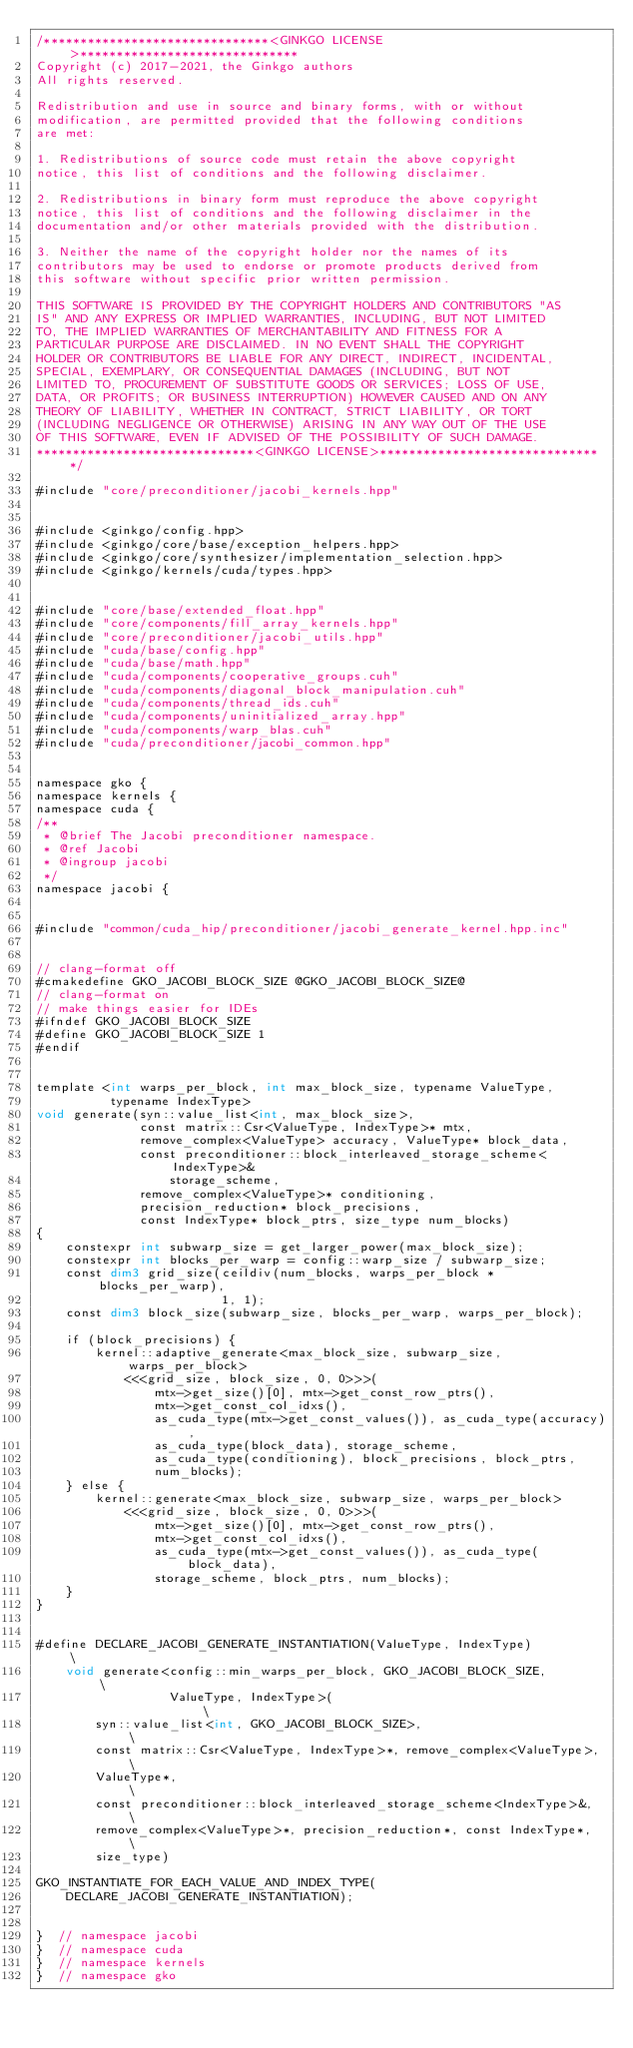<code> <loc_0><loc_0><loc_500><loc_500><_Cuda_>/*******************************<GINKGO LICENSE>******************************
Copyright (c) 2017-2021, the Ginkgo authors
All rights reserved.

Redistribution and use in source and binary forms, with or without
modification, are permitted provided that the following conditions
are met:

1. Redistributions of source code must retain the above copyright
notice, this list of conditions and the following disclaimer.

2. Redistributions in binary form must reproduce the above copyright
notice, this list of conditions and the following disclaimer in the
documentation and/or other materials provided with the distribution.

3. Neither the name of the copyright holder nor the names of its
contributors may be used to endorse or promote products derived from
this software without specific prior written permission.

THIS SOFTWARE IS PROVIDED BY THE COPYRIGHT HOLDERS AND CONTRIBUTORS "AS
IS" AND ANY EXPRESS OR IMPLIED WARRANTIES, INCLUDING, BUT NOT LIMITED
TO, THE IMPLIED WARRANTIES OF MERCHANTABILITY AND FITNESS FOR A
PARTICULAR PURPOSE ARE DISCLAIMED. IN NO EVENT SHALL THE COPYRIGHT
HOLDER OR CONTRIBUTORS BE LIABLE FOR ANY DIRECT, INDIRECT, INCIDENTAL,
SPECIAL, EXEMPLARY, OR CONSEQUENTIAL DAMAGES (INCLUDING, BUT NOT
LIMITED TO, PROCUREMENT OF SUBSTITUTE GOODS OR SERVICES; LOSS OF USE,
DATA, OR PROFITS; OR BUSINESS INTERRUPTION) HOWEVER CAUSED AND ON ANY
THEORY OF LIABILITY, WHETHER IN CONTRACT, STRICT LIABILITY, OR TORT
(INCLUDING NEGLIGENCE OR OTHERWISE) ARISING IN ANY WAY OUT OF THE USE
OF THIS SOFTWARE, EVEN IF ADVISED OF THE POSSIBILITY OF SUCH DAMAGE.
******************************<GINKGO LICENSE>*******************************/

#include "core/preconditioner/jacobi_kernels.hpp"


#include <ginkgo/config.hpp>
#include <ginkgo/core/base/exception_helpers.hpp>
#include <ginkgo/core/synthesizer/implementation_selection.hpp>
#include <ginkgo/kernels/cuda/types.hpp>


#include "core/base/extended_float.hpp"
#include "core/components/fill_array_kernels.hpp"
#include "core/preconditioner/jacobi_utils.hpp"
#include "cuda/base/config.hpp"
#include "cuda/base/math.hpp"
#include "cuda/components/cooperative_groups.cuh"
#include "cuda/components/diagonal_block_manipulation.cuh"
#include "cuda/components/thread_ids.cuh"
#include "cuda/components/uninitialized_array.hpp"
#include "cuda/components/warp_blas.cuh"
#include "cuda/preconditioner/jacobi_common.hpp"


namespace gko {
namespace kernels {
namespace cuda {
/**
 * @brief The Jacobi preconditioner namespace.
 * @ref Jacobi
 * @ingroup jacobi
 */
namespace jacobi {


#include "common/cuda_hip/preconditioner/jacobi_generate_kernel.hpp.inc"


// clang-format off
#cmakedefine GKO_JACOBI_BLOCK_SIZE @GKO_JACOBI_BLOCK_SIZE@
// clang-format on
// make things easier for IDEs
#ifndef GKO_JACOBI_BLOCK_SIZE
#define GKO_JACOBI_BLOCK_SIZE 1
#endif


template <int warps_per_block, int max_block_size, typename ValueType,
          typename IndexType>
void generate(syn::value_list<int, max_block_size>,
              const matrix::Csr<ValueType, IndexType>* mtx,
              remove_complex<ValueType> accuracy, ValueType* block_data,
              const preconditioner::block_interleaved_storage_scheme<IndexType>&
                  storage_scheme,
              remove_complex<ValueType>* conditioning,
              precision_reduction* block_precisions,
              const IndexType* block_ptrs, size_type num_blocks)
{
    constexpr int subwarp_size = get_larger_power(max_block_size);
    constexpr int blocks_per_warp = config::warp_size / subwarp_size;
    const dim3 grid_size(ceildiv(num_blocks, warps_per_block * blocks_per_warp),
                         1, 1);
    const dim3 block_size(subwarp_size, blocks_per_warp, warps_per_block);

    if (block_precisions) {
        kernel::adaptive_generate<max_block_size, subwarp_size, warps_per_block>
            <<<grid_size, block_size, 0, 0>>>(
                mtx->get_size()[0], mtx->get_const_row_ptrs(),
                mtx->get_const_col_idxs(),
                as_cuda_type(mtx->get_const_values()), as_cuda_type(accuracy),
                as_cuda_type(block_data), storage_scheme,
                as_cuda_type(conditioning), block_precisions, block_ptrs,
                num_blocks);
    } else {
        kernel::generate<max_block_size, subwarp_size, warps_per_block>
            <<<grid_size, block_size, 0, 0>>>(
                mtx->get_size()[0], mtx->get_const_row_ptrs(),
                mtx->get_const_col_idxs(),
                as_cuda_type(mtx->get_const_values()), as_cuda_type(block_data),
                storage_scheme, block_ptrs, num_blocks);
    }
}


#define DECLARE_JACOBI_GENERATE_INSTANTIATION(ValueType, IndexType)          \
    void generate<config::min_warps_per_block, GKO_JACOBI_BLOCK_SIZE,        \
                  ValueType, IndexType>(                                     \
        syn::value_list<int, GKO_JACOBI_BLOCK_SIZE>,                         \
        const matrix::Csr<ValueType, IndexType>*, remove_complex<ValueType>, \
        ValueType*,                                                          \
        const preconditioner::block_interleaved_storage_scheme<IndexType>&,  \
        remove_complex<ValueType>*, precision_reduction*, const IndexType*,  \
        size_type)

GKO_INSTANTIATE_FOR_EACH_VALUE_AND_INDEX_TYPE(
    DECLARE_JACOBI_GENERATE_INSTANTIATION);


}  // namespace jacobi
}  // namespace cuda
}  // namespace kernels
}  // namespace gko
</code> 